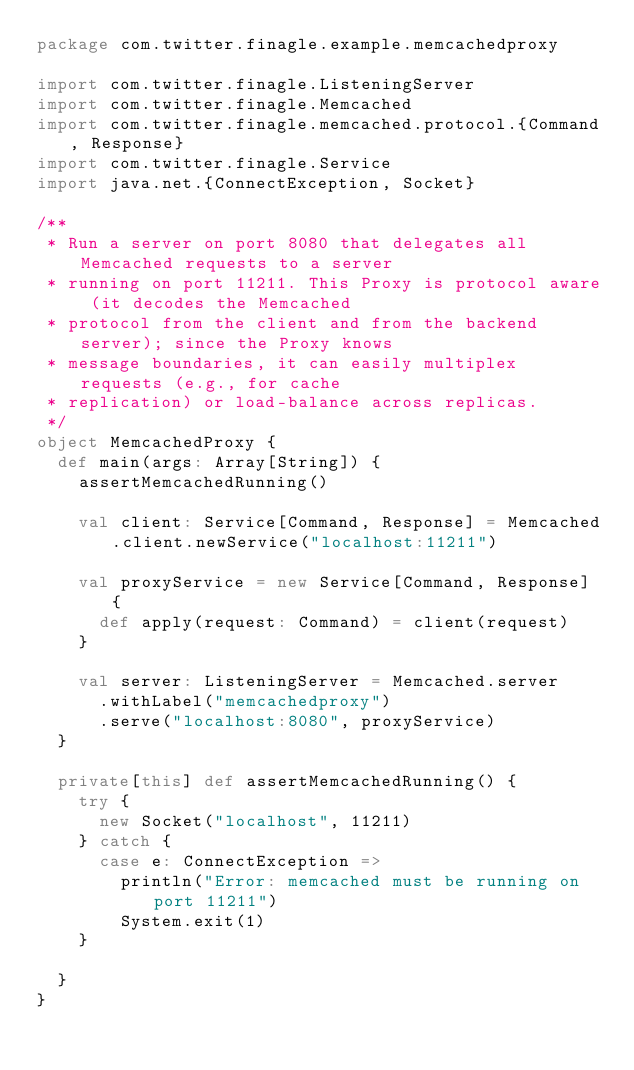<code> <loc_0><loc_0><loc_500><loc_500><_Scala_>package com.twitter.finagle.example.memcachedproxy

import com.twitter.finagle.ListeningServer
import com.twitter.finagle.Memcached
import com.twitter.finagle.memcached.protocol.{Command, Response}
import com.twitter.finagle.Service
import java.net.{ConnectException, Socket}

/**
 * Run a server on port 8080 that delegates all Memcached requests to a server
 * running on port 11211. This Proxy is protocol aware (it decodes the Memcached
 * protocol from the client and from the backend server); since the Proxy knows
 * message boundaries, it can easily multiplex requests (e.g., for cache
 * replication) or load-balance across replicas.
 */
object MemcachedProxy {
  def main(args: Array[String]) {
    assertMemcachedRunning()

    val client: Service[Command, Response] = Memcached.client.newService("localhost:11211")

    val proxyService = new Service[Command, Response] {
      def apply(request: Command) = client(request)
    }

    val server: ListeningServer = Memcached.server
      .withLabel("memcachedproxy")
      .serve("localhost:8080", proxyService)
  }

  private[this] def assertMemcachedRunning() {
    try {
      new Socket("localhost", 11211)
    } catch {
      case e: ConnectException =>
        println("Error: memcached must be running on port 11211")
        System.exit(1)
    }

  }
}
</code> 